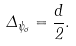<formula> <loc_0><loc_0><loc_500><loc_500>\Delta _ { \psi _ { \sigma } } = \frac { d } 2 .</formula> 